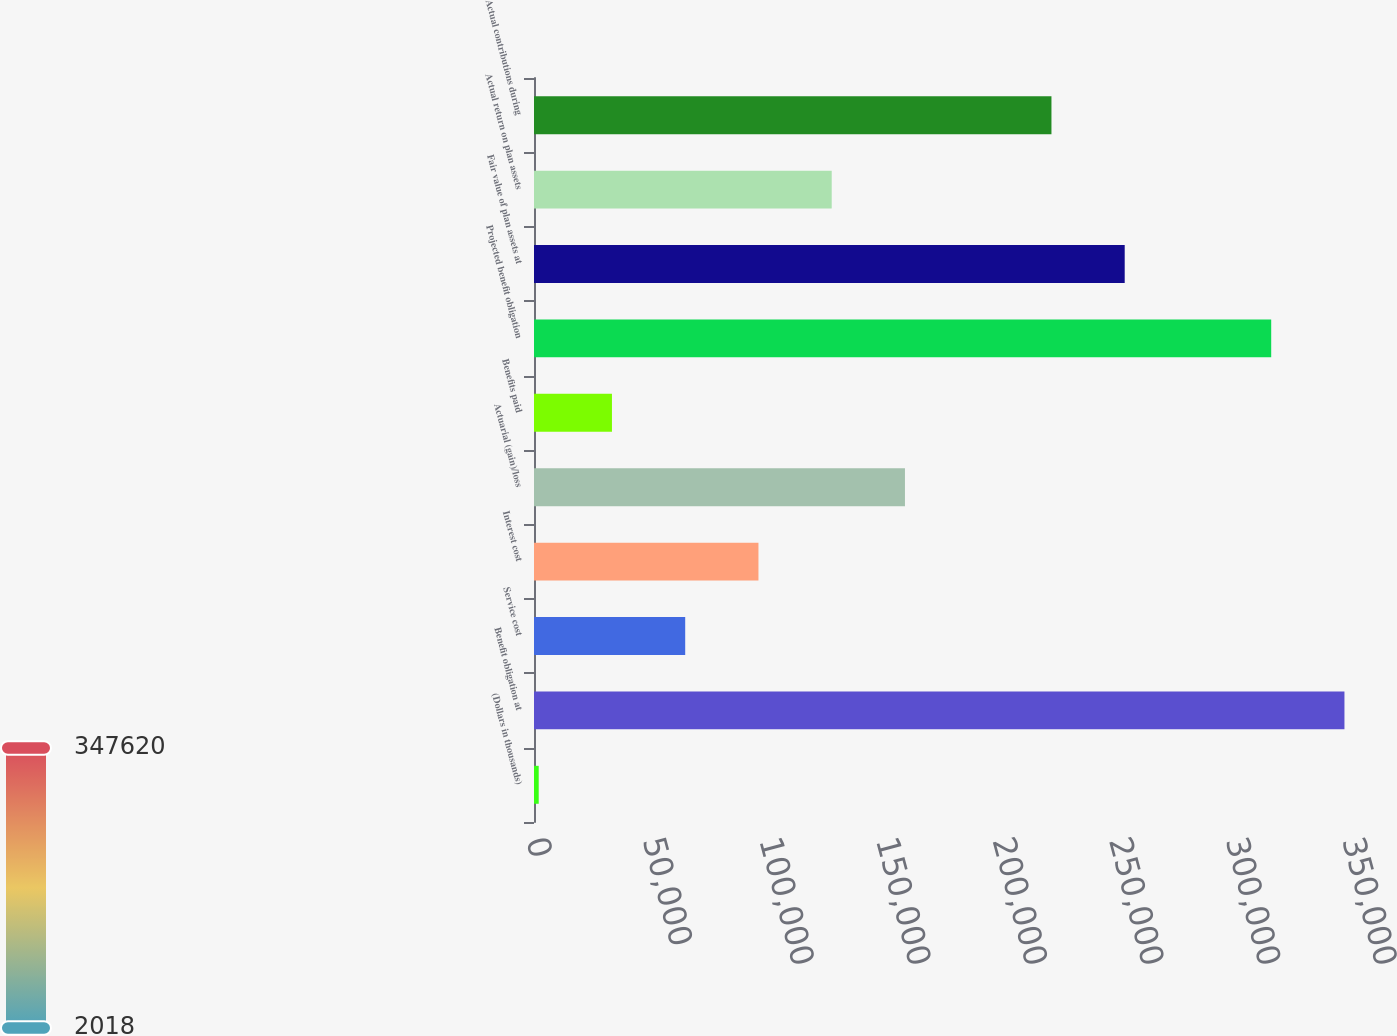<chart> <loc_0><loc_0><loc_500><loc_500><bar_chart><fcel>(Dollars in thousands)<fcel>Benefit obligation at<fcel>Service cost<fcel>Interest cost<fcel>Actuarial (gain)/loss<fcel>Benefits paid<fcel>Projected benefit obligation<fcel>Fair value of plan assets at<fcel>Actual return on plan assets<fcel>Actual contributions during<nl><fcel>2018<fcel>347620<fcel>64854.8<fcel>96273.2<fcel>159110<fcel>33436.4<fcel>316202<fcel>253365<fcel>127692<fcel>221947<nl></chart> 